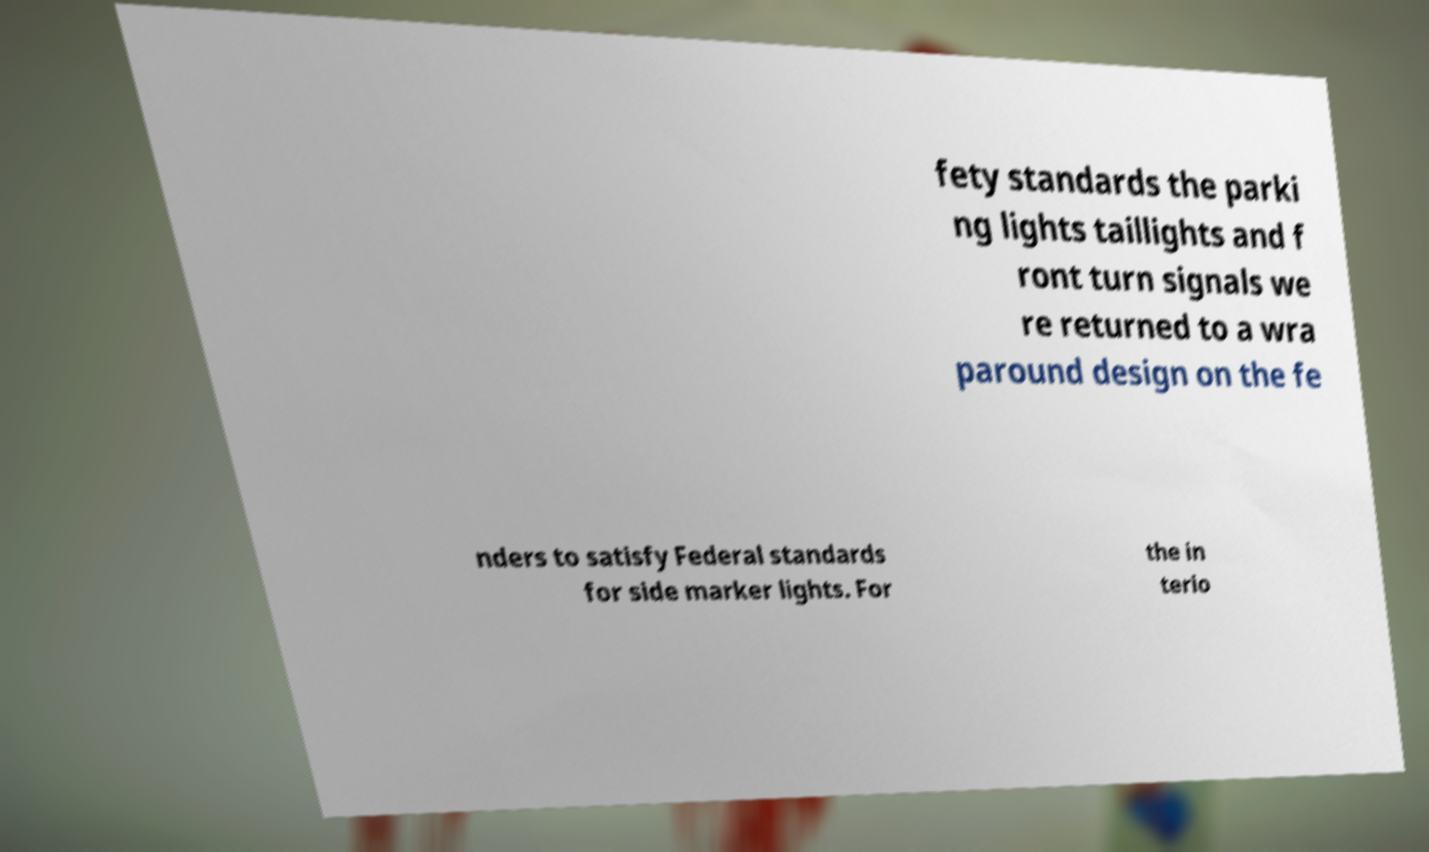Please identify and transcribe the text found in this image. fety standards the parki ng lights taillights and f ront turn signals we re returned to a wra paround design on the fe nders to satisfy Federal standards for side marker lights. For the in terio 